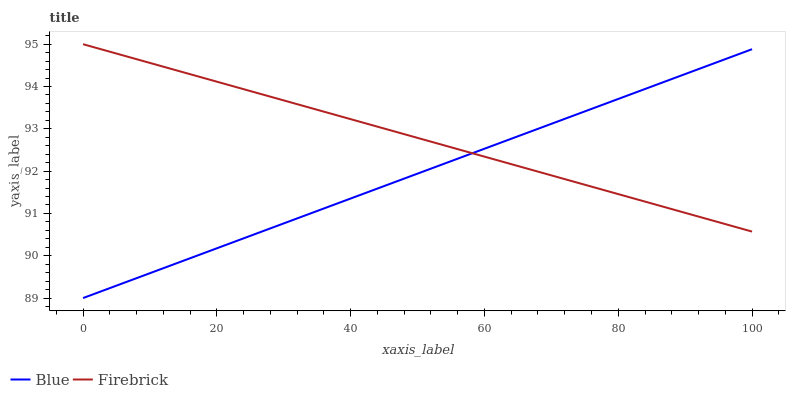Does Blue have the minimum area under the curve?
Answer yes or no. Yes. Does Firebrick have the maximum area under the curve?
Answer yes or no. Yes. Does Firebrick have the minimum area under the curve?
Answer yes or no. No. Is Firebrick the smoothest?
Answer yes or no. Yes. Is Blue the roughest?
Answer yes or no. Yes. Is Firebrick the roughest?
Answer yes or no. No. Does Blue have the lowest value?
Answer yes or no. Yes. Does Firebrick have the lowest value?
Answer yes or no. No. Does Firebrick have the highest value?
Answer yes or no. Yes. Does Blue intersect Firebrick?
Answer yes or no. Yes. Is Blue less than Firebrick?
Answer yes or no. No. Is Blue greater than Firebrick?
Answer yes or no. No. 